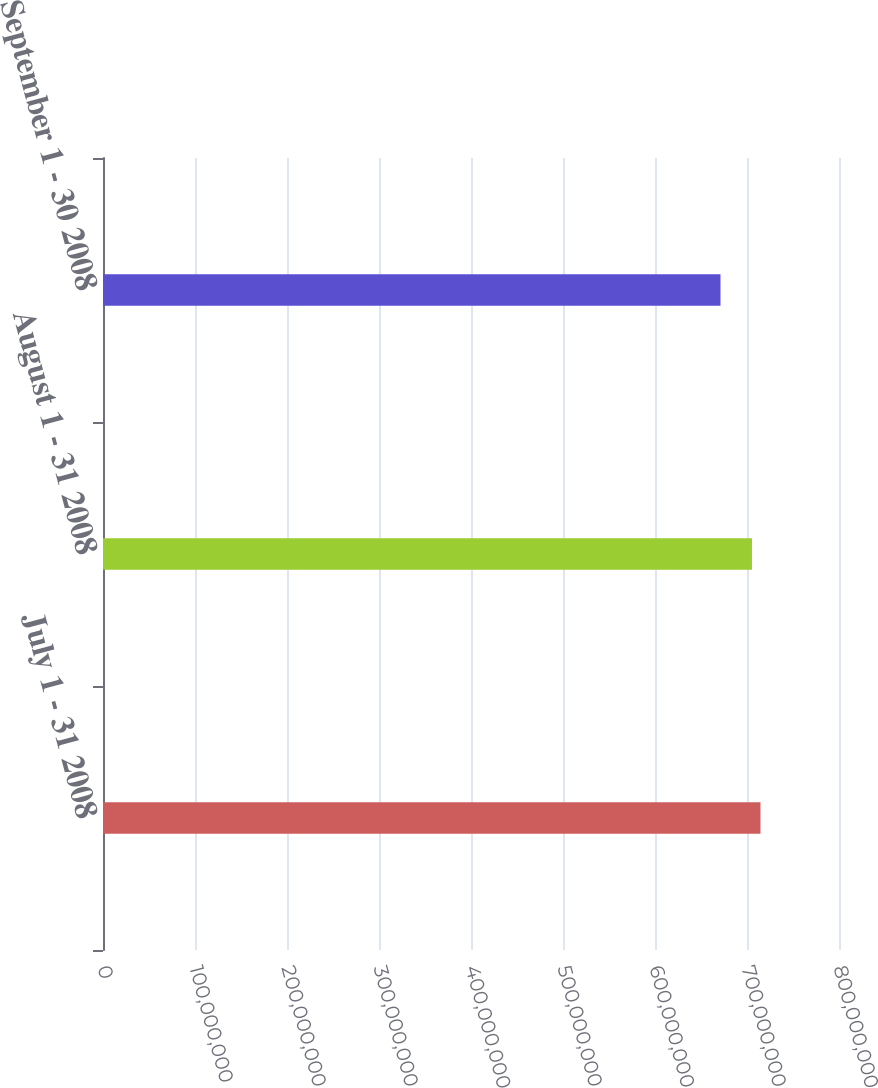Convert chart to OTSL. <chart><loc_0><loc_0><loc_500><loc_500><bar_chart><fcel>July 1 - 31 2008<fcel>August 1 - 31 2008<fcel>September 1 - 30 2008<nl><fcel>7.1465e+08<fcel>7.05412e+08<fcel>6.71188e+08<nl></chart> 